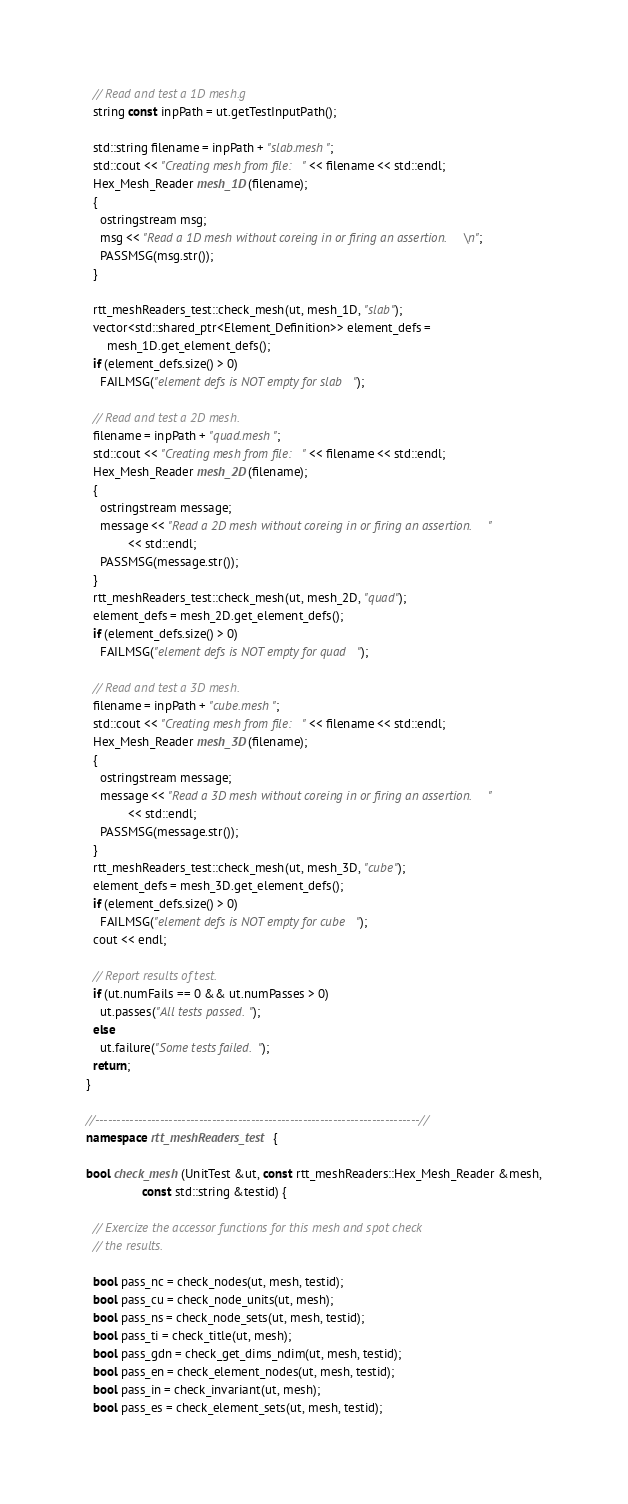Convert code to text. <code><loc_0><loc_0><loc_500><loc_500><_C++_>
  // Read and test a 1D mesh.g
  string const inpPath = ut.getTestInputPath();

  std::string filename = inpPath + "slab.mesh";
  std::cout << "Creating mesh from file: " << filename << std::endl;
  Hex_Mesh_Reader mesh_1D(filename);
  {
    ostringstream msg;
    msg << "Read a 1D mesh without coreing in or firing an assertion.\n";
    PASSMSG(msg.str());
  }

  rtt_meshReaders_test::check_mesh(ut, mesh_1D, "slab");
  vector<std::shared_ptr<Element_Definition>> element_defs =
      mesh_1D.get_element_defs();
  if (element_defs.size() > 0)
    FAILMSG("element defs is NOT empty for slab");

  // Read and test a 2D mesh.
  filename = inpPath + "quad.mesh";
  std::cout << "Creating mesh from file: " << filename << std::endl;
  Hex_Mesh_Reader mesh_2D(filename);
  {
    ostringstream message;
    message << "Read a 2D mesh without coreing in or firing an assertion."
            << std::endl;
    PASSMSG(message.str());
  }
  rtt_meshReaders_test::check_mesh(ut, mesh_2D, "quad");
  element_defs = mesh_2D.get_element_defs();
  if (element_defs.size() > 0)
    FAILMSG("element defs is NOT empty for quad");

  // Read and test a 3D mesh.
  filename = inpPath + "cube.mesh";
  std::cout << "Creating mesh from file: " << filename << std::endl;
  Hex_Mesh_Reader mesh_3D(filename);
  {
    ostringstream message;
    message << "Read a 3D mesh without coreing in or firing an assertion."
            << std::endl;
    PASSMSG(message.str());
  }
  rtt_meshReaders_test::check_mesh(ut, mesh_3D, "cube");
  element_defs = mesh_3D.get_element_defs();
  if (element_defs.size() > 0)
    FAILMSG("element defs is NOT empty for cube");
  cout << endl;

  // Report results of test.
  if (ut.numFails == 0 && ut.numPasses > 0)
    ut.passes("All tests passed.");
  else
    ut.failure("Some tests failed.");
  return;
}

//---------------------------------------------------------------------------//
namespace rtt_meshReaders_test {

bool check_mesh(UnitTest &ut, const rtt_meshReaders::Hex_Mesh_Reader &mesh,
                const std::string &testid) {

  // Exercize the accessor functions for this mesh and spot check
  // the results.

  bool pass_nc = check_nodes(ut, mesh, testid);
  bool pass_cu = check_node_units(ut, mesh);
  bool pass_ns = check_node_sets(ut, mesh, testid);
  bool pass_ti = check_title(ut, mesh);
  bool pass_gdn = check_get_dims_ndim(ut, mesh, testid);
  bool pass_en = check_element_nodes(ut, mesh, testid);
  bool pass_in = check_invariant(ut, mesh);
  bool pass_es = check_element_sets(ut, mesh, testid);</code> 